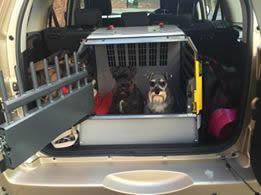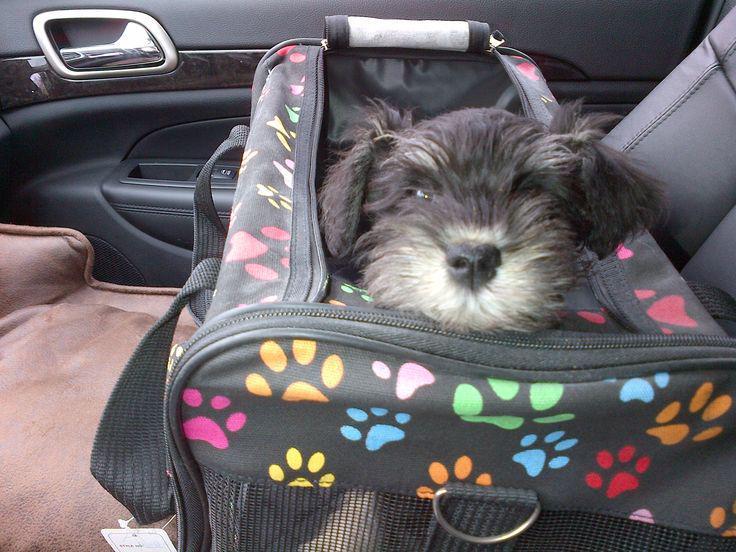The first image is the image on the left, the second image is the image on the right. Given the left and right images, does the statement "There is a black dog in both images." hold true? Answer yes or no. Yes. The first image is the image on the left, the second image is the image on the right. For the images shown, is this caption "there is no more then four dogs" true? Answer yes or no. Yes. 